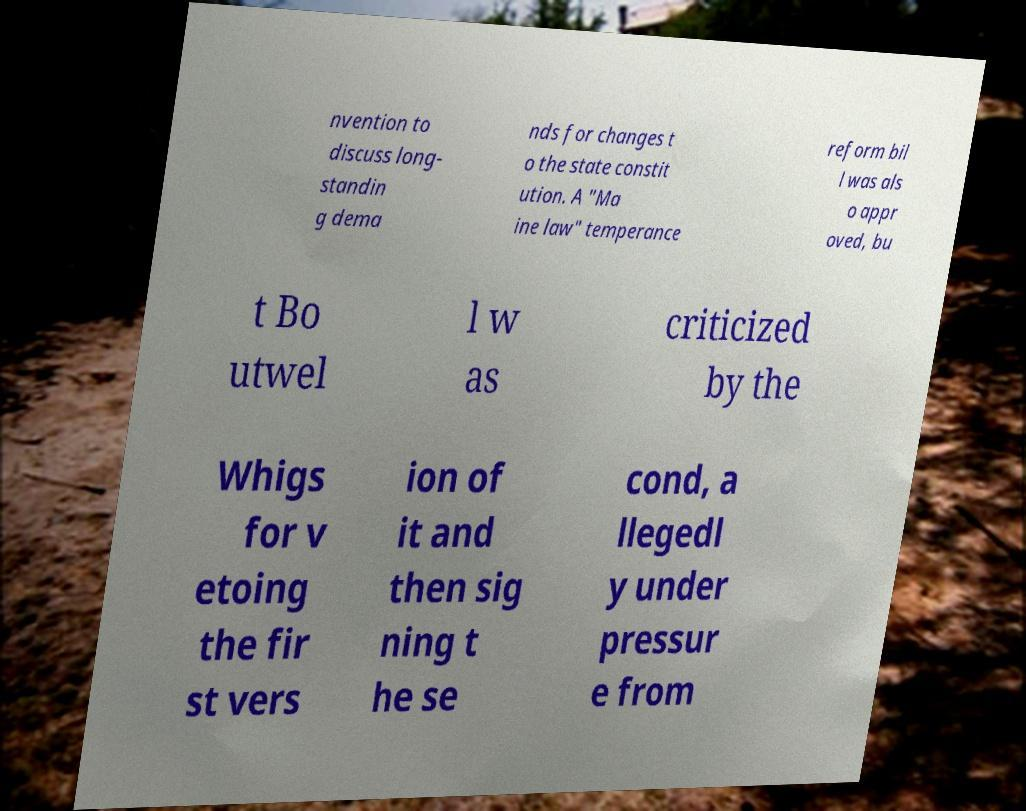I need the written content from this picture converted into text. Can you do that? nvention to discuss long- standin g dema nds for changes t o the state constit ution. A "Ma ine law" temperance reform bil l was als o appr oved, bu t Bo utwel l w as criticized by the Whigs for v etoing the fir st vers ion of it and then sig ning t he se cond, a llegedl y under pressur e from 